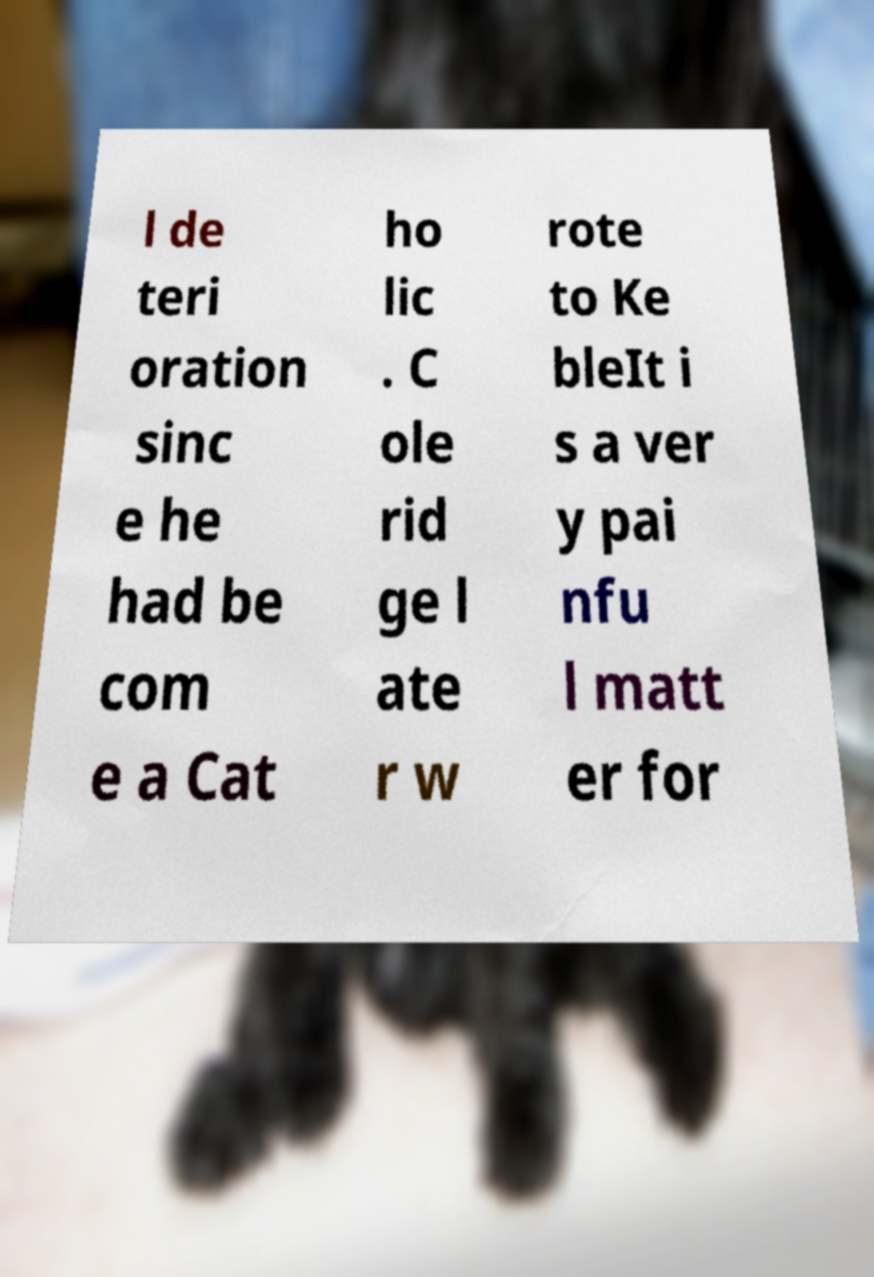I need the written content from this picture converted into text. Can you do that? l de teri oration sinc e he had be com e a Cat ho lic . C ole rid ge l ate r w rote to Ke bleIt i s a ver y pai nfu l matt er for 